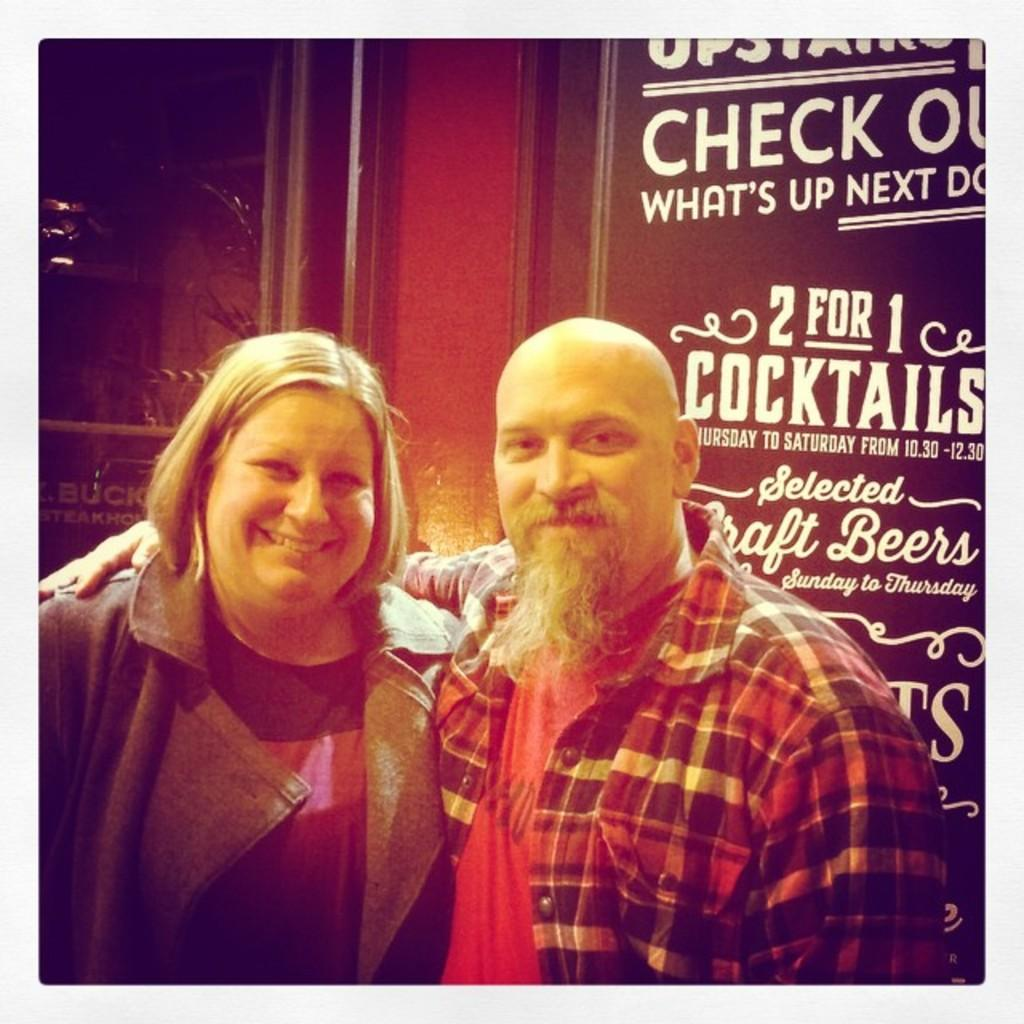Who are the people in the image? There is a boy and a girl in the image. What are the expressions on their faces? Both the boy and the girl are smiling. What can be seen in the background of the image? There is a wall with text in the background of the image. What type of jelly is being used as a prop in the image? There is no jelly present in the image. Can you see a rifle in the hands of either the boy or the girl? No, there is no rifle visible in the image. 